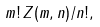Convert formula to latex. <formula><loc_0><loc_0><loc_500><loc_500>m ! \, Z ( m , n ) / n ! ,</formula> 